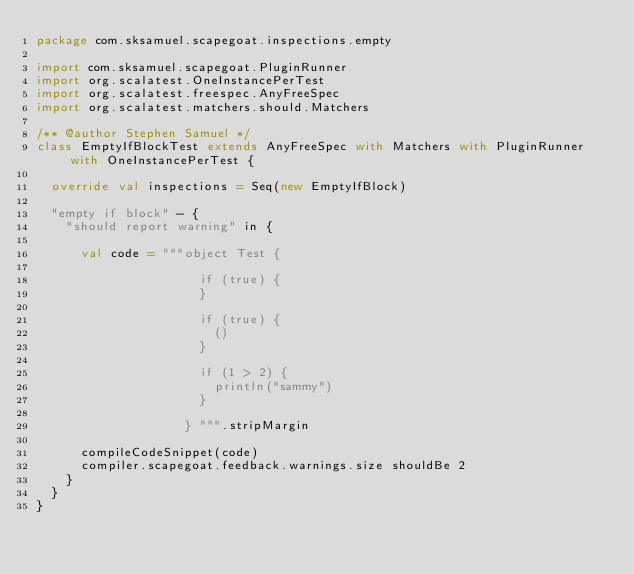Convert code to text. <code><loc_0><loc_0><loc_500><loc_500><_Scala_>package com.sksamuel.scapegoat.inspections.empty

import com.sksamuel.scapegoat.PluginRunner
import org.scalatest.OneInstancePerTest
import org.scalatest.freespec.AnyFreeSpec
import org.scalatest.matchers.should.Matchers

/** @author Stephen Samuel */
class EmptyIfBlockTest extends AnyFreeSpec with Matchers with PluginRunner with OneInstancePerTest {

  override val inspections = Seq(new EmptyIfBlock)

  "empty if block" - {
    "should report warning" in {

      val code = """object Test {

                      if (true) {
                      }

                      if (true) {
                        ()
                      }

                      if (1 > 2) {
                        println("sammy")
                      }

                    } """.stripMargin

      compileCodeSnippet(code)
      compiler.scapegoat.feedback.warnings.size shouldBe 2
    }
  }
}
</code> 